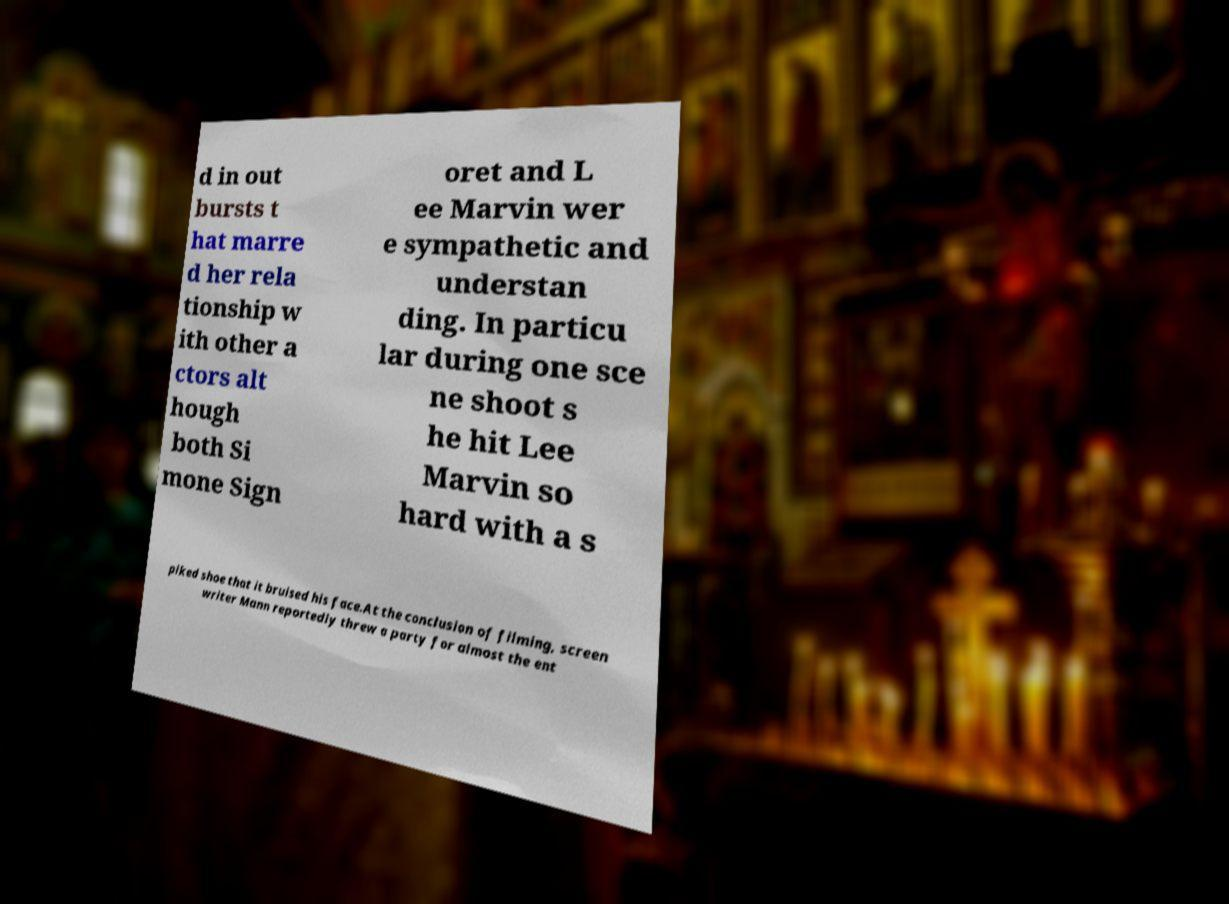What messages or text are displayed in this image? I need them in a readable, typed format. d in out bursts t hat marre d her rela tionship w ith other a ctors alt hough both Si mone Sign oret and L ee Marvin wer e sympathetic and understan ding. In particu lar during one sce ne shoot s he hit Lee Marvin so hard with a s piked shoe that it bruised his face.At the conclusion of filming, screen writer Mann reportedly threw a party for almost the ent 